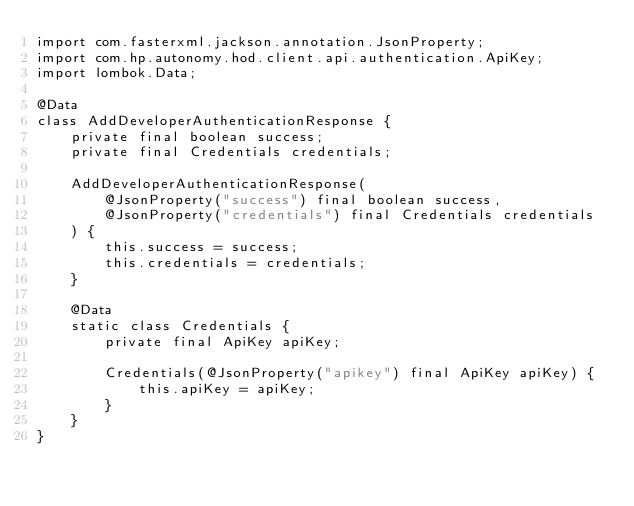Convert code to text. <code><loc_0><loc_0><loc_500><loc_500><_Java_>import com.fasterxml.jackson.annotation.JsonProperty;
import com.hp.autonomy.hod.client.api.authentication.ApiKey;
import lombok.Data;

@Data
class AddDeveloperAuthenticationResponse {
    private final boolean success;
    private final Credentials credentials;

    AddDeveloperAuthenticationResponse(
        @JsonProperty("success") final boolean success,
        @JsonProperty("credentials") final Credentials credentials
    ) {
        this.success = success;
        this.credentials = credentials;
    }

    @Data
    static class Credentials {
        private final ApiKey apiKey;

        Credentials(@JsonProperty("apikey") final ApiKey apiKey) {
            this.apiKey = apiKey;
        }
    }
}
</code> 